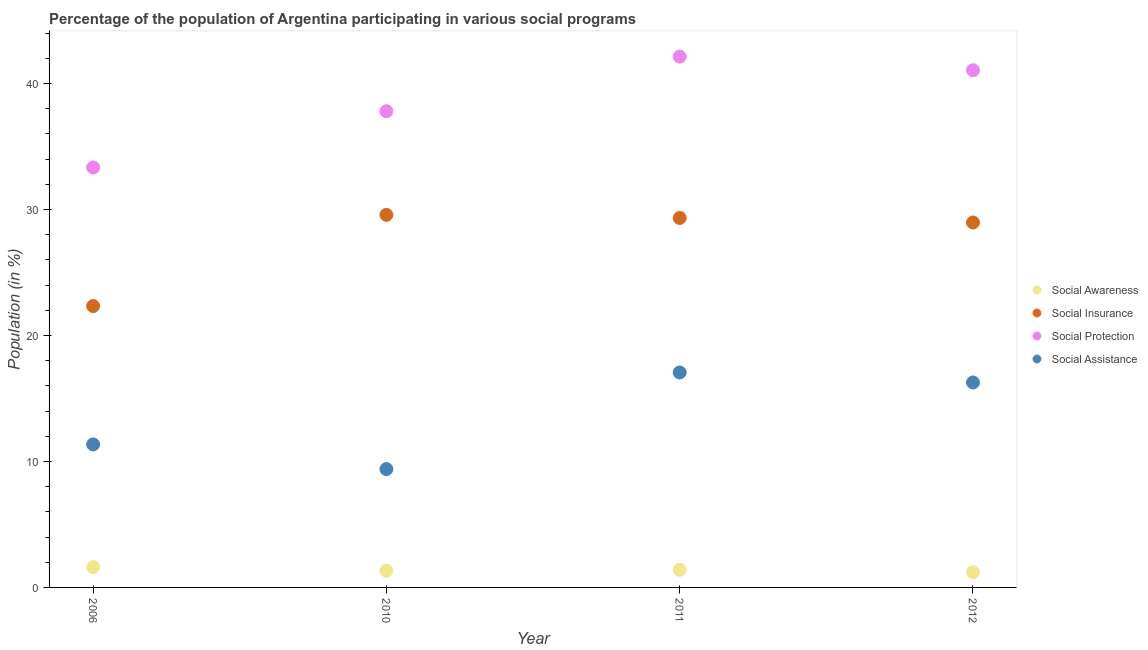What is the participation of population in social protection programs in 2010?
Your answer should be compact. 37.8. Across all years, what is the maximum participation of population in social protection programs?
Your answer should be very brief. 42.14. Across all years, what is the minimum participation of population in social insurance programs?
Your answer should be compact. 22.34. In which year was the participation of population in social insurance programs minimum?
Offer a terse response. 2006. What is the total participation of population in social assistance programs in the graph?
Your answer should be compact. 54.08. What is the difference between the participation of population in social awareness programs in 2010 and that in 2012?
Keep it short and to the point. 0.13. What is the difference between the participation of population in social protection programs in 2010 and the participation of population in social assistance programs in 2006?
Provide a short and direct response. 26.45. What is the average participation of population in social insurance programs per year?
Your response must be concise. 27.55. In the year 2011, what is the difference between the participation of population in social awareness programs and participation of population in social protection programs?
Offer a very short reply. -40.74. What is the ratio of the participation of population in social assistance programs in 2006 to that in 2012?
Keep it short and to the point. 0.7. Is the participation of population in social insurance programs in 2006 less than that in 2012?
Provide a short and direct response. Yes. Is the difference between the participation of population in social protection programs in 2006 and 2010 greater than the difference between the participation of population in social assistance programs in 2006 and 2010?
Ensure brevity in your answer.  No. What is the difference between the highest and the second highest participation of population in social protection programs?
Provide a succinct answer. 1.08. What is the difference between the highest and the lowest participation of population in social assistance programs?
Provide a succinct answer. 7.67. Is it the case that in every year, the sum of the participation of population in social protection programs and participation of population in social insurance programs is greater than the sum of participation of population in social awareness programs and participation of population in social assistance programs?
Your answer should be compact. Yes. Is it the case that in every year, the sum of the participation of population in social awareness programs and participation of population in social insurance programs is greater than the participation of population in social protection programs?
Your answer should be compact. No. Does the participation of population in social protection programs monotonically increase over the years?
Give a very brief answer. No. Is the participation of population in social assistance programs strictly greater than the participation of population in social protection programs over the years?
Your response must be concise. No. Is the participation of population in social insurance programs strictly less than the participation of population in social protection programs over the years?
Your response must be concise. Yes. Are the values on the major ticks of Y-axis written in scientific E-notation?
Give a very brief answer. No. Does the graph contain any zero values?
Ensure brevity in your answer.  No. How are the legend labels stacked?
Offer a terse response. Vertical. What is the title of the graph?
Provide a short and direct response. Percentage of the population of Argentina participating in various social programs . What is the label or title of the X-axis?
Ensure brevity in your answer.  Year. What is the label or title of the Y-axis?
Your response must be concise. Population (in %). What is the Population (in %) in Social Awareness in 2006?
Provide a short and direct response. 1.62. What is the Population (in %) in Social Insurance in 2006?
Give a very brief answer. 22.34. What is the Population (in %) of Social Protection in 2006?
Give a very brief answer. 33.34. What is the Population (in %) of Social Assistance in 2006?
Ensure brevity in your answer.  11.35. What is the Population (in %) of Social Awareness in 2010?
Make the answer very short. 1.33. What is the Population (in %) in Social Insurance in 2010?
Your response must be concise. 29.58. What is the Population (in %) in Social Protection in 2010?
Provide a succinct answer. 37.8. What is the Population (in %) of Social Assistance in 2010?
Provide a succinct answer. 9.39. What is the Population (in %) of Social Awareness in 2011?
Offer a terse response. 1.4. What is the Population (in %) in Social Insurance in 2011?
Ensure brevity in your answer.  29.33. What is the Population (in %) of Social Protection in 2011?
Make the answer very short. 42.14. What is the Population (in %) in Social Assistance in 2011?
Your answer should be compact. 17.06. What is the Population (in %) in Social Awareness in 2012?
Offer a terse response. 1.21. What is the Population (in %) in Social Insurance in 2012?
Your answer should be very brief. 28.97. What is the Population (in %) of Social Protection in 2012?
Ensure brevity in your answer.  41.05. What is the Population (in %) of Social Assistance in 2012?
Make the answer very short. 16.27. Across all years, what is the maximum Population (in %) in Social Awareness?
Make the answer very short. 1.62. Across all years, what is the maximum Population (in %) of Social Insurance?
Provide a short and direct response. 29.58. Across all years, what is the maximum Population (in %) in Social Protection?
Keep it short and to the point. 42.14. Across all years, what is the maximum Population (in %) in Social Assistance?
Offer a terse response. 17.06. Across all years, what is the minimum Population (in %) in Social Awareness?
Your answer should be compact. 1.21. Across all years, what is the minimum Population (in %) in Social Insurance?
Keep it short and to the point. 22.34. Across all years, what is the minimum Population (in %) of Social Protection?
Make the answer very short. 33.34. Across all years, what is the minimum Population (in %) of Social Assistance?
Ensure brevity in your answer.  9.39. What is the total Population (in %) of Social Awareness in the graph?
Ensure brevity in your answer.  5.56. What is the total Population (in %) in Social Insurance in the graph?
Provide a succinct answer. 110.22. What is the total Population (in %) in Social Protection in the graph?
Your answer should be compact. 154.33. What is the total Population (in %) in Social Assistance in the graph?
Your answer should be very brief. 54.08. What is the difference between the Population (in %) in Social Awareness in 2006 and that in 2010?
Give a very brief answer. 0.28. What is the difference between the Population (in %) of Social Insurance in 2006 and that in 2010?
Keep it short and to the point. -7.24. What is the difference between the Population (in %) in Social Protection in 2006 and that in 2010?
Your response must be concise. -4.47. What is the difference between the Population (in %) in Social Assistance in 2006 and that in 2010?
Your answer should be very brief. 1.96. What is the difference between the Population (in %) in Social Awareness in 2006 and that in 2011?
Ensure brevity in your answer.  0.21. What is the difference between the Population (in %) in Social Insurance in 2006 and that in 2011?
Offer a terse response. -6.99. What is the difference between the Population (in %) in Social Protection in 2006 and that in 2011?
Provide a succinct answer. -8.8. What is the difference between the Population (in %) of Social Assistance in 2006 and that in 2011?
Give a very brief answer. -5.71. What is the difference between the Population (in %) of Social Awareness in 2006 and that in 2012?
Provide a short and direct response. 0.41. What is the difference between the Population (in %) of Social Insurance in 2006 and that in 2012?
Give a very brief answer. -6.63. What is the difference between the Population (in %) of Social Protection in 2006 and that in 2012?
Ensure brevity in your answer.  -7.72. What is the difference between the Population (in %) of Social Assistance in 2006 and that in 2012?
Provide a succinct answer. -4.92. What is the difference between the Population (in %) in Social Awareness in 2010 and that in 2011?
Keep it short and to the point. -0.07. What is the difference between the Population (in %) of Social Insurance in 2010 and that in 2011?
Your answer should be compact. 0.24. What is the difference between the Population (in %) in Social Protection in 2010 and that in 2011?
Give a very brief answer. -4.34. What is the difference between the Population (in %) of Social Assistance in 2010 and that in 2011?
Your answer should be very brief. -7.67. What is the difference between the Population (in %) in Social Awareness in 2010 and that in 2012?
Provide a short and direct response. 0.13. What is the difference between the Population (in %) of Social Insurance in 2010 and that in 2012?
Keep it short and to the point. 0.61. What is the difference between the Population (in %) of Social Protection in 2010 and that in 2012?
Your answer should be very brief. -3.25. What is the difference between the Population (in %) of Social Assistance in 2010 and that in 2012?
Offer a terse response. -6.88. What is the difference between the Population (in %) of Social Awareness in 2011 and that in 2012?
Offer a terse response. 0.2. What is the difference between the Population (in %) of Social Insurance in 2011 and that in 2012?
Keep it short and to the point. 0.36. What is the difference between the Population (in %) of Social Protection in 2011 and that in 2012?
Your answer should be very brief. 1.08. What is the difference between the Population (in %) of Social Assistance in 2011 and that in 2012?
Your response must be concise. 0.79. What is the difference between the Population (in %) of Social Awareness in 2006 and the Population (in %) of Social Insurance in 2010?
Your response must be concise. -27.96. What is the difference between the Population (in %) in Social Awareness in 2006 and the Population (in %) in Social Protection in 2010?
Your answer should be compact. -36.18. What is the difference between the Population (in %) of Social Awareness in 2006 and the Population (in %) of Social Assistance in 2010?
Your response must be concise. -7.78. What is the difference between the Population (in %) of Social Insurance in 2006 and the Population (in %) of Social Protection in 2010?
Provide a short and direct response. -15.46. What is the difference between the Population (in %) in Social Insurance in 2006 and the Population (in %) in Social Assistance in 2010?
Your response must be concise. 12.94. What is the difference between the Population (in %) in Social Protection in 2006 and the Population (in %) in Social Assistance in 2010?
Your response must be concise. 23.94. What is the difference between the Population (in %) in Social Awareness in 2006 and the Population (in %) in Social Insurance in 2011?
Your response must be concise. -27.72. What is the difference between the Population (in %) of Social Awareness in 2006 and the Population (in %) of Social Protection in 2011?
Make the answer very short. -40.52. What is the difference between the Population (in %) of Social Awareness in 2006 and the Population (in %) of Social Assistance in 2011?
Your answer should be very brief. -15.45. What is the difference between the Population (in %) of Social Insurance in 2006 and the Population (in %) of Social Protection in 2011?
Ensure brevity in your answer.  -19.8. What is the difference between the Population (in %) of Social Insurance in 2006 and the Population (in %) of Social Assistance in 2011?
Provide a succinct answer. 5.27. What is the difference between the Population (in %) in Social Protection in 2006 and the Population (in %) in Social Assistance in 2011?
Offer a very short reply. 16.27. What is the difference between the Population (in %) of Social Awareness in 2006 and the Population (in %) of Social Insurance in 2012?
Keep it short and to the point. -27.35. What is the difference between the Population (in %) of Social Awareness in 2006 and the Population (in %) of Social Protection in 2012?
Offer a very short reply. -39.44. What is the difference between the Population (in %) in Social Awareness in 2006 and the Population (in %) in Social Assistance in 2012?
Ensure brevity in your answer.  -14.65. What is the difference between the Population (in %) of Social Insurance in 2006 and the Population (in %) of Social Protection in 2012?
Provide a short and direct response. -18.72. What is the difference between the Population (in %) of Social Insurance in 2006 and the Population (in %) of Social Assistance in 2012?
Make the answer very short. 6.07. What is the difference between the Population (in %) of Social Protection in 2006 and the Population (in %) of Social Assistance in 2012?
Make the answer very short. 17.07. What is the difference between the Population (in %) of Social Awareness in 2010 and the Population (in %) of Social Insurance in 2011?
Make the answer very short. -28. What is the difference between the Population (in %) in Social Awareness in 2010 and the Population (in %) in Social Protection in 2011?
Your response must be concise. -40.81. What is the difference between the Population (in %) of Social Awareness in 2010 and the Population (in %) of Social Assistance in 2011?
Provide a succinct answer. -15.73. What is the difference between the Population (in %) in Social Insurance in 2010 and the Population (in %) in Social Protection in 2011?
Keep it short and to the point. -12.56. What is the difference between the Population (in %) in Social Insurance in 2010 and the Population (in %) in Social Assistance in 2011?
Offer a very short reply. 12.51. What is the difference between the Population (in %) of Social Protection in 2010 and the Population (in %) of Social Assistance in 2011?
Offer a very short reply. 20.74. What is the difference between the Population (in %) of Social Awareness in 2010 and the Population (in %) of Social Insurance in 2012?
Ensure brevity in your answer.  -27.64. What is the difference between the Population (in %) in Social Awareness in 2010 and the Population (in %) in Social Protection in 2012?
Ensure brevity in your answer.  -39.72. What is the difference between the Population (in %) of Social Awareness in 2010 and the Population (in %) of Social Assistance in 2012?
Provide a short and direct response. -14.94. What is the difference between the Population (in %) in Social Insurance in 2010 and the Population (in %) in Social Protection in 2012?
Provide a short and direct response. -11.48. What is the difference between the Population (in %) of Social Insurance in 2010 and the Population (in %) of Social Assistance in 2012?
Give a very brief answer. 13.31. What is the difference between the Population (in %) of Social Protection in 2010 and the Population (in %) of Social Assistance in 2012?
Offer a very short reply. 21.53. What is the difference between the Population (in %) of Social Awareness in 2011 and the Population (in %) of Social Insurance in 2012?
Your answer should be very brief. -27.57. What is the difference between the Population (in %) of Social Awareness in 2011 and the Population (in %) of Social Protection in 2012?
Keep it short and to the point. -39.65. What is the difference between the Population (in %) of Social Awareness in 2011 and the Population (in %) of Social Assistance in 2012?
Provide a succinct answer. -14.87. What is the difference between the Population (in %) of Social Insurance in 2011 and the Population (in %) of Social Protection in 2012?
Give a very brief answer. -11.72. What is the difference between the Population (in %) of Social Insurance in 2011 and the Population (in %) of Social Assistance in 2012?
Keep it short and to the point. 13.06. What is the difference between the Population (in %) in Social Protection in 2011 and the Population (in %) in Social Assistance in 2012?
Your response must be concise. 25.87. What is the average Population (in %) of Social Awareness per year?
Your response must be concise. 1.39. What is the average Population (in %) in Social Insurance per year?
Provide a short and direct response. 27.55. What is the average Population (in %) of Social Protection per year?
Give a very brief answer. 38.58. What is the average Population (in %) of Social Assistance per year?
Your response must be concise. 13.52. In the year 2006, what is the difference between the Population (in %) of Social Awareness and Population (in %) of Social Insurance?
Your answer should be very brief. -20.72. In the year 2006, what is the difference between the Population (in %) of Social Awareness and Population (in %) of Social Protection?
Give a very brief answer. -31.72. In the year 2006, what is the difference between the Population (in %) of Social Awareness and Population (in %) of Social Assistance?
Keep it short and to the point. -9.74. In the year 2006, what is the difference between the Population (in %) of Social Insurance and Population (in %) of Social Protection?
Offer a terse response. -11. In the year 2006, what is the difference between the Population (in %) of Social Insurance and Population (in %) of Social Assistance?
Your response must be concise. 10.98. In the year 2006, what is the difference between the Population (in %) of Social Protection and Population (in %) of Social Assistance?
Offer a very short reply. 21.98. In the year 2010, what is the difference between the Population (in %) of Social Awareness and Population (in %) of Social Insurance?
Offer a terse response. -28.24. In the year 2010, what is the difference between the Population (in %) of Social Awareness and Population (in %) of Social Protection?
Keep it short and to the point. -36.47. In the year 2010, what is the difference between the Population (in %) in Social Awareness and Population (in %) in Social Assistance?
Provide a succinct answer. -8.06. In the year 2010, what is the difference between the Population (in %) in Social Insurance and Population (in %) in Social Protection?
Your answer should be very brief. -8.23. In the year 2010, what is the difference between the Population (in %) in Social Insurance and Population (in %) in Social Assistance?
Provide a succinct answer. 20.18. In the year 2010, what is the difference between the Population (in %) in Social Protection and Population (in %) in Social Assistance?
Provide a succinct answer. 28.41. In the year 2011, what is the difference between the Population (in %) of Social Awareness and Population (in %) of Social Insurance?
Keep it short and to the point. -27.93. In the year 2011, what is the difference between the Population (in %) of Social Awareness and Population (in %) of Social Protection?
Provide a short and direct response. -40.73. In the year 2011, what is the difference between the Population (in %) of Social Awareness and Population (in %) of Social Assistance?
Offer a very short reply. -15.66. In the year 2011, what is the difference between the Population (in %) in Social Insurance and Population (in %) in Social Protection?
Provide a short and direct response. -12.81. In the year 2011, what is the difference between the Population (in %) in Social Insurance and Population (in %) in Social Assistance?
Provide a short and direct response. 12.27. In the year 2011, what is the difference between the Population (in %) in Social Protection and Population (in %) in Social Assistance?
Your answer should be very brief. 25.07. In the year 2012, what is the difference between the Population (in %) of Social Awareness and Population (in %) of Social Insurance?
Offer a very short reply. -27.76. In the year 2012, what is the difference between the Population (in %) in Social Awareness and Population (in %) in Social Protection?
Offer a terse response. -39.85. In the year 2012, what is the difference between the Population (in %) of Social Awareness and Population (in %) of Social Assistance?
Keep it short and to the point. -15.06. In the year 2012, what is the difference between the Population (in %) of Social Insurance and Population (in %) of Social Protection?
Your answer should be compact. -12.09. In the year 2012, what is the difference between the Population (in %) in Social Insurance and Population (in %) in Social Assistance?
Your answer should be very brief. 12.7. In the year 2012, what is the difference between the Population (in %) of Social Protection and Population (in %) of Social Assistance?
Give a very brief answer. 24.79. What is the ratio of the Population (in %) in Social Awareness in 2006 to that in 2010?
Your response must be concise. 1.21. What is the ratio of the Population (in %) of Social Insurance in 2006 to that in 2010?
Offer a terse response. 0.76. What is the ratio of the Population (in %) in Social Protection in 2006 to that in 2010?
Provide a succinct answer. 0.88. What is the ratio of the Population (in %) of Social Assistance in 2006 to that in 2010?
Make the answer very short. 1.21. What is the ratio of the Population (in %) of Social Awareness in 2006 to that in 2011?
Give a very brief answer. 1.15. What is the ratio of the Population (in %) of Social Insurance in 2006 to that in 2011?
Your answer should be very brief. 0.76. What is the ratio of the Population (in %) of Social Protection in 2006 to that in 2011?
Offer a very short reply. 0.79. What is the ratio of the Population (in %) in Social Assistance in 2006 to that in 2011?
Your answer should be very brief. 0.67. What is the ratio of the Population (in %) of Social Awareness in 2006 to that in 2012?
Make the answer very short. 1.34. What is the ratio of the Population (in %) of Social Insurance in 2006 to that in 2012?
Your answer should be very brief. 0.77. What is the ratio of the Population (in %) in Social Protection in 2006 to that in 2012?
Your answer should be very brief. 0.81. What is the ratio of the Population (in %) in Social Assistance in 2006 to that in 2012?
Offer a very short reply. 0.7. What is the ratio of the Population (in %) of Social Awareness in 2010 to that in 2011?
Offer a terse response. 0.95. What is the ratio of the Population (in %) in Social Insurance in 2010 to that in 2011?
Ensure brevity in your answer.  1.01. What is the ratio of the Population (in %) in Social Protection in 2010 to that in 2011?
Your response must be concise. 0.9. What is the ratio of the Population (in %) in Social Assistance in 2010 to that in 2011?
Provide a succinct answer. 0.55. What is the ratio of the Population (in %) in Social Awareness in 2010 to that in 2012?
Ensure brevity in your answer.  1.1. What is the ratio of the Population (in %) of Social Insurance in 2010 to that in 2012?
Give a very brief answer. 1.02. What is the ratio of the Population (in %) in Social Protection in 2010 to that in 2012?
Provide a short and direct response. 0.92. What is the ratio of the Population (in %) in Social Assistance in 2010 to that in 2012?
Your answer should be compact. 0.58. What is the ratio of the Population (in %) in Social Awareness in 2011 to that in 2012?
Your response must be concise. 1.16. What is the ratio of the Population (in %) of Social Insurance in 2011 to that in 2012?
Provide a succinct answer. 1.01. What is the ratio of the Population (in %) in Social Protection in 2011 to that in 2012?
Provide a short and direct response. 1.03. What is the ratio of the Population (in %) in Social Assistance in 2011 to that in 2012?
Offer a very short reply. 1.05. What is the difference between the highest and the second highest Population (in %) in Social Awareness?
Give a very brief answer. 0.21. What is the difference between the highest and the second highest Population (in %) in Social Insurance?
Your answer should be very brief. 0.24. What is the difference between the highest and the second highest Population (in %) in Social Protection?
Your answer should be very brief. 1.08. What is the difference between the highest and the second highest Population (in %) in Social Assistance?
Provide a succinct answer. 0.79. What is the difference between the highest and the lowest Population (in %) of Social Awareness?
Your answer should be compact. 0.41. What is the difference between the highest and the lowest Population (in %) of Social Insurance?
Your response must be concise. 7.24. What is the difference between the highest and the lowest Population (in %) of Social Protection?
Keep it short and to the point. 8.8. What is the difference between the highest and the lowest Population (in %) of Social Assistance?
Your response must be concise. 7.67. 